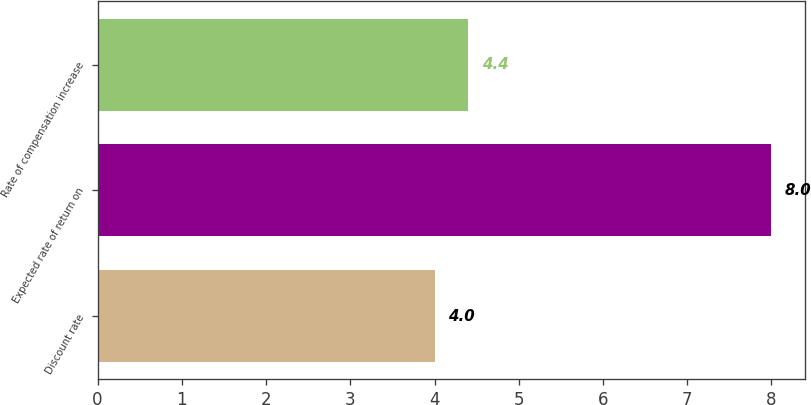Convert chart. <chart><loc_0><loc_0><loc_500><loc_500><bar_chart><fcel>Discount rate<fcel>Expected rate of return on<fcel>Rate of compensation increase<nl><fcel>4<fcel>8<fcel>4.4<nl></chart> 